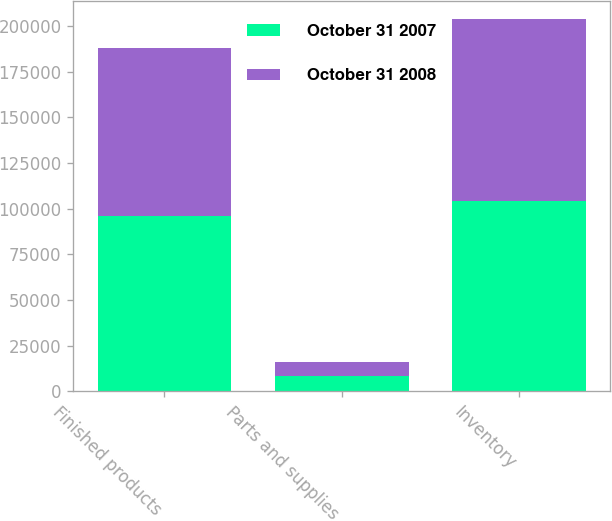Convert chart. <chart><loc_0><loc_0><loc_500><loc_500><stacked_bar_chart><ecel><fcel>Finished products<fcel>Parts and supplies<fcel>Inventory<nl><fcel>October 31 2007<fcel>96139<fcel>8096<fcel>104235<nl><fcel>October 31 2008<fcel>91512<fcel>7819<fcel>99331<nl></chart> 